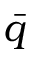Convert formula to latex. <formula><loc_0><loc_0><loc_500><loc_500>\bar { q }</formula> 